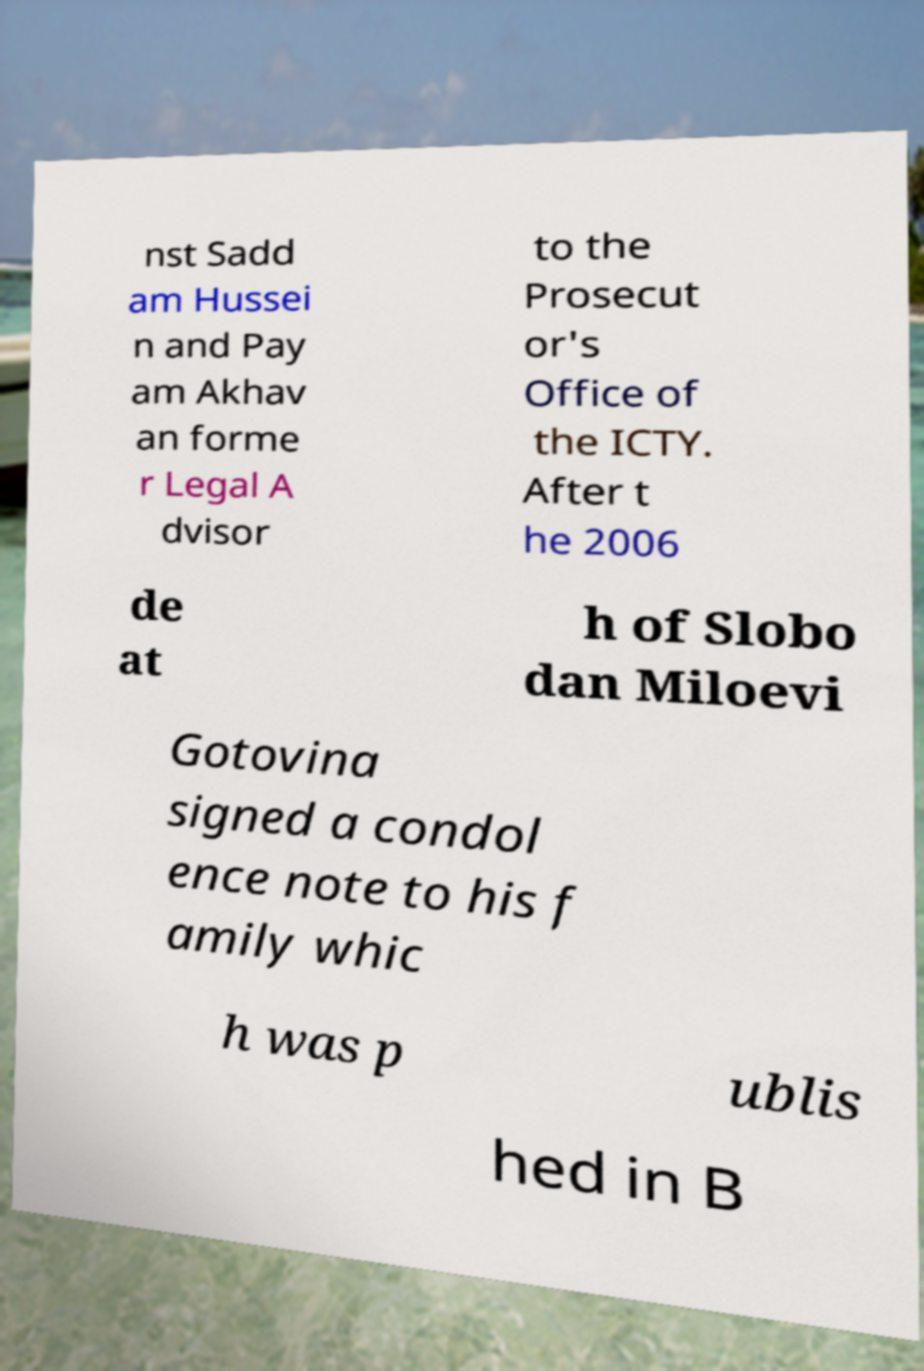Can you accurately transcribe the text from the provided image for me? nst Sadd am Hussei n and Pay am Akhav an forme r Legal A dvisor to the Prosecut or's Office of the ICTY. After t he 2006 de at h of Slobo dan Miloevi Gotovina signed a condol ence note to his f amily whic h was p ublis hed in B 